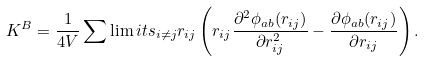Convert formula to latex. <formula><loc_0><loc_0><loc_500><loc_500>K ^ { B } = \frac { 1 } { 4 V } \sum \lim i t s _ { i \ne j } r _ { i j } \left ( r _ { i j } \frac { \partial ^ { 2 } \phi _ { a b } ( r _ { i j } ) } { \partial r _ { i j } ^ { 2 } } - \frac { \partial \phi _ { a b } ( r _ { i j } ) } { \partial r _ { i j } } \right ) .</formula> 